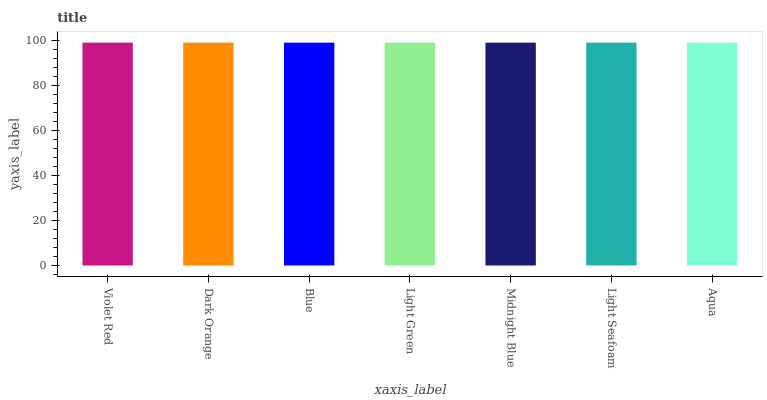Is Aqua the minimum?
Answer yes or no. Yes. Is Violet Red the maximum?
Answer yes or no. Yes. Is Dark Orange the minimum?
Answer yes or no. No. Is Dark Orange the maximum?
Answer yes or no. No. Is Violet Red greater than Dark Orange?
Answer yes or no. Yes. Is Dark Orange less than Violet Red?
Answer yes or no. Yes. Is Dark Orange greater than Violet Red?
Answer yes or no. No. Is Violet Red less than Dark Orange?
Answer yes or no. No. Is Light Green the high median?
Answer yes or no. Yes. Is Light Green the low median?
Answer yes or no. Yes. Is Aqua the high median?
Answer yes or no. No. Is Light Seafoam the low median?
Answer yes or no. No. 